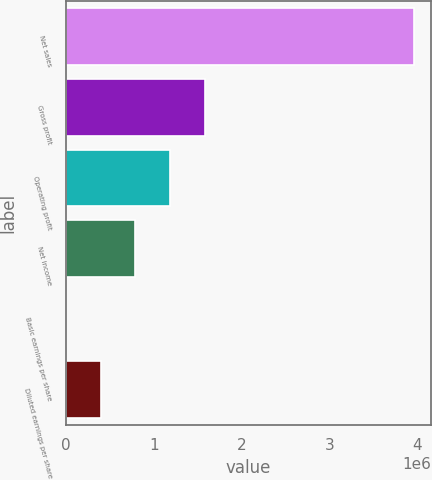Convert chart. <chart><loc_0><loc_0><loc_500><loc_500><bar_chart><fcel>Net sales<fcel>Gross profit<fcel>Operating profit<fcel>Net income<fcel>Basic earnings per share<fcel>Diluted earnings per share<nl><fcel>3.96465e+06<fcel>1.58586e+06<fcel>1.18939e+06<fcel>792930<fcel>0.62<fcel>396465<nl></chart> 